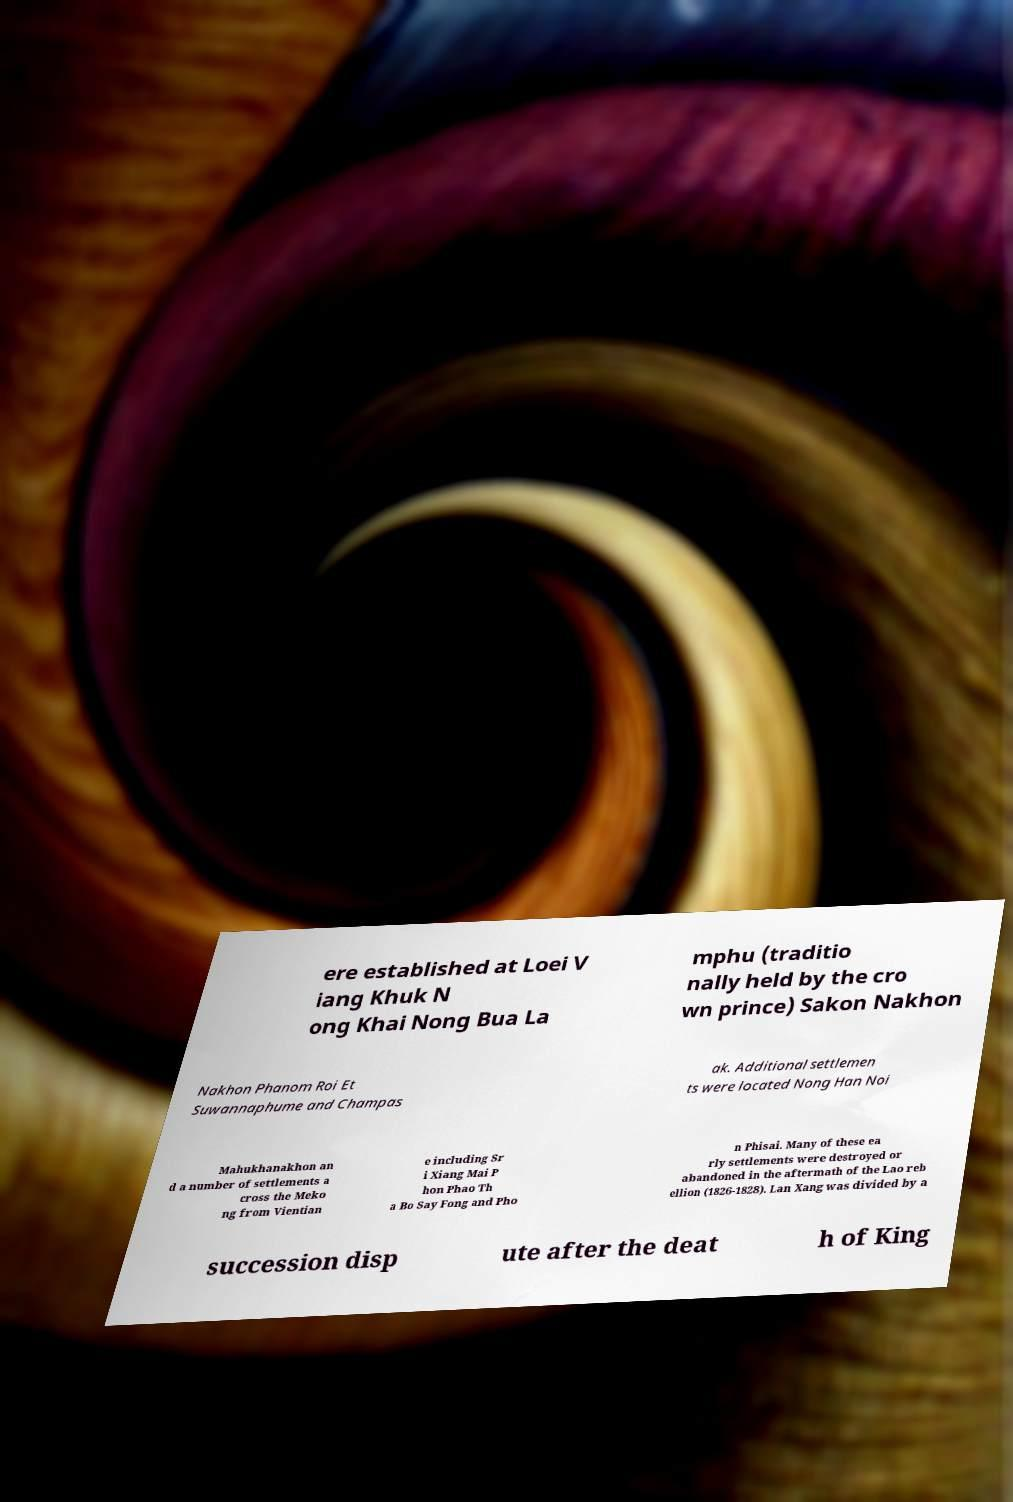What messages or text are displayed in this image? I need them in a readable, typed format. ere established at Loei V iang Khuk N ong Khai Nong Bua La mphu (traditio nally held by the cro wn prince) Sakon Nakhon Nakhon Phanom Roi Et Suwannaphume and Champas ak. Additional settlemen ts were located Nong Han Noi Mahukhanakhon an d a number of settlements a cross the Meko ng from Vientian e including Sr i Xiang Mai P hon Phao Th a Bo Say Fong and Pho n Phisai. Many of these ea rly settlements were destroyed or abandoned in the aftermath of the Lao reb ellion (1826-1828). Lan Xang was divided by a succession disp ute after the deat h of King 